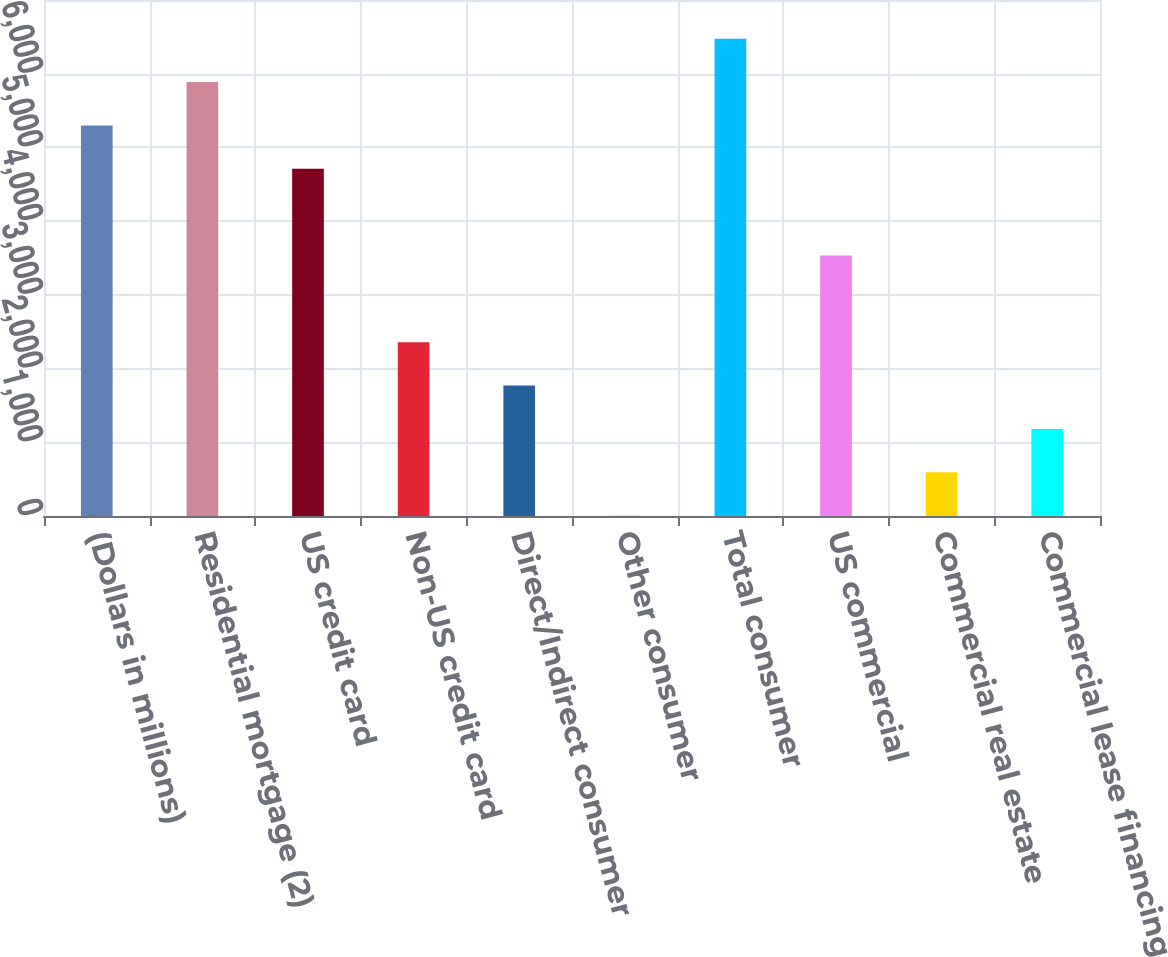Convert chart to OTSL. <chart><loc_0><loc_0><loc_500><loc_500><bar_chart><fcel>(Dollars in millions)<fcel>Residential mortgage (2)<fcel>US credit card<fcel>Non-US credit card<fcel>Direct/Indirect consumer<fcel>Other consumer<fcel>Total consumer<fcel>US commercial<fcel>Commercial real estate<fcel>Commercial lease financing<nl><fcel>5298.7<fcel>5887<fcel>4710.4<fcel>2357.2<fcel>1768.9<fcel>4<fcel>6475.3<fcel>3533.8<fcel>592.3<fcel>1180.6<nl></chart> 